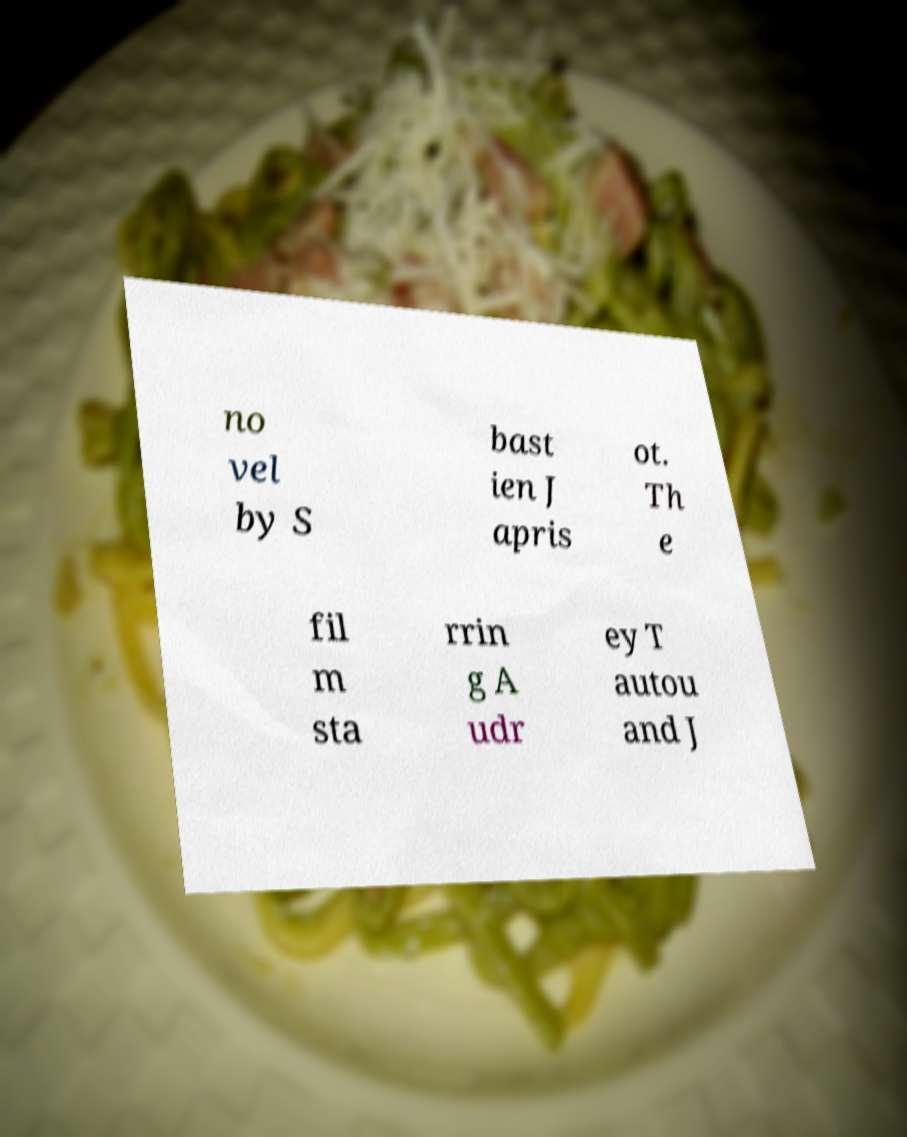Could you extract and type out the text from this image? no vel by S bast ien J apris ot. Th e fil m sta rrin g A udr ey T autou and J 